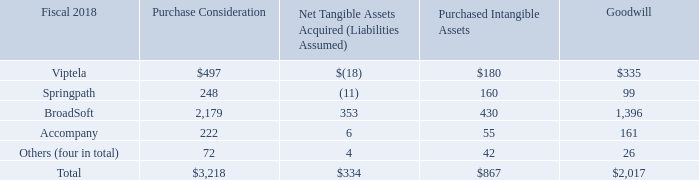Fiscal 2018 Acquisitions
Allocation of the purchase consideration for acquisitions completed in fiscal 2018 is summarized as follows (in millions):
On July 31, 2017, we completed our acquisition of privately held Viptela Inc. (“Viptela”), a provider of software-defined wide area networking products. Revenue from the Viptela acquisition has been included in our Infrastructure Platforms product category.
On September 22, 2017, we completed our acquisition of privately held Springpath, Inc. (“Springpath”), a hyperconvergence software company. Revenue from the Springpath acquisition has been included in our Infrastructure Platforms product category.
On February 1, 2018, we completed our acquisition of publicly held BroadSoft, Inc. (“BroadSoft”), a cloud calling and contact center solutions company. Revenue from the BroadSoft acquisition has been included in our Applications product category.
On May 10, 2018, we completed our acquisition of privately held Accompany, a provider of an AI-driven relationship intelligence platform. Results from the Accompany acquisition has been included in our Applications product category.
The total purchase consideration related to our acquisitions completed during fiscal 2018 consisted of cash consideration and vested share-based awards assumed. The total cash and cash equivalents acquired from these acquisitions was approximately $187 million.
What was the amount of Purchased Considerations for BroadSoft?
Answer scale should be: million. 2,179. What was the amount of Purchased Intangible Assets for Springpath?
Answer scale should be: million. 160. What were the companies acquired in 2017? Viptela inc. (“viptela”), springpath, inc. (“springpath”). What was the difference in Purchase Consideration between Springpath and Broadsoft?
Answer scale should be: million. 2,179-248
Answer: 1931. What was Goodwill from Others companies as a percentage of total Goodwill?
Answer scale should be: percent. 26/2,017
Answer: 1.29. What was the difference in Purchased Intangible Assets between Viptela and Springpath?
Answer scale should be: million. 180-160
Answer: 20. 